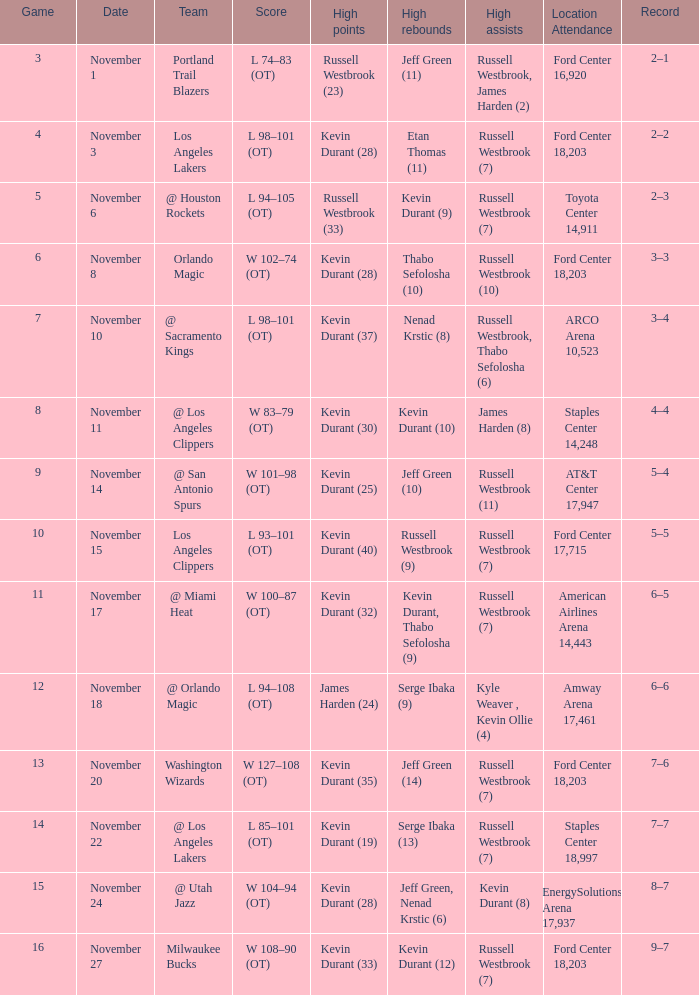What was the record in the game in which Jeff Green (14) did the most high rebounds? 7–6. 